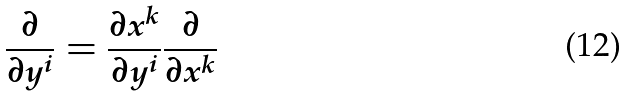Convert formula to latex. <formula><loc_0><loc_0><loc_500><loc_500>\frac { \partial } { \partial y ^ { i } } = \frac { \partial x ^ { k } } { \partial y ^ { i } } \frac { \partial } { \partial x ^ { k } }</formula> 